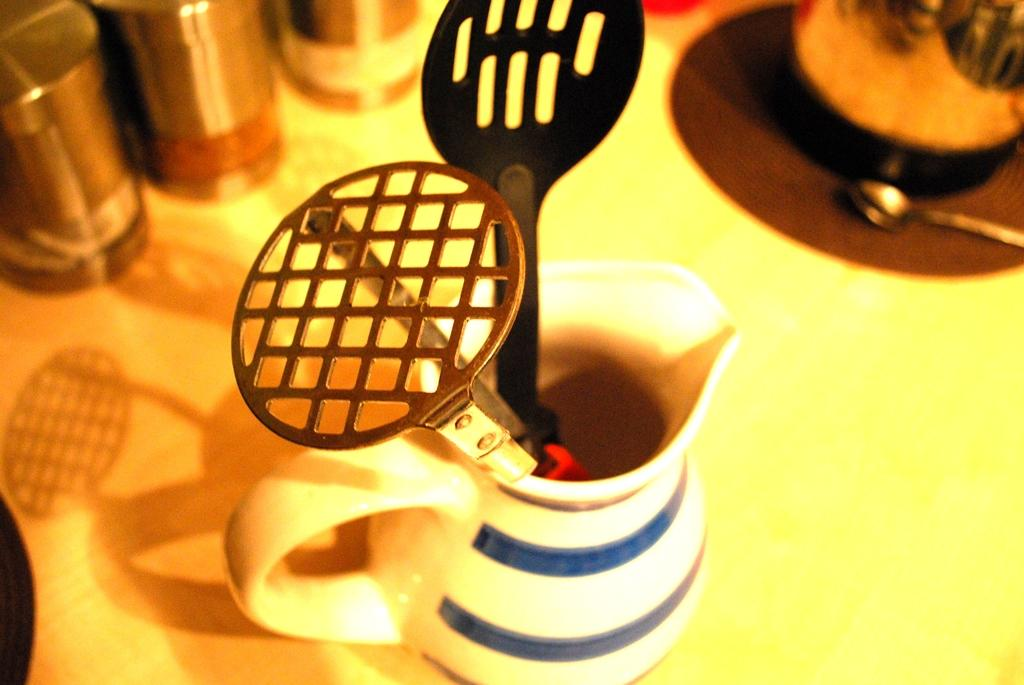What utensil is visible in the image? There is a spoon in the image. What is the location of the objects in the image? The objects are on a platform and in a holder in the image. What type of pet can be seen playing with the spoon in the image? There is no pet present in the image, and therefore no such activity can be observed. 